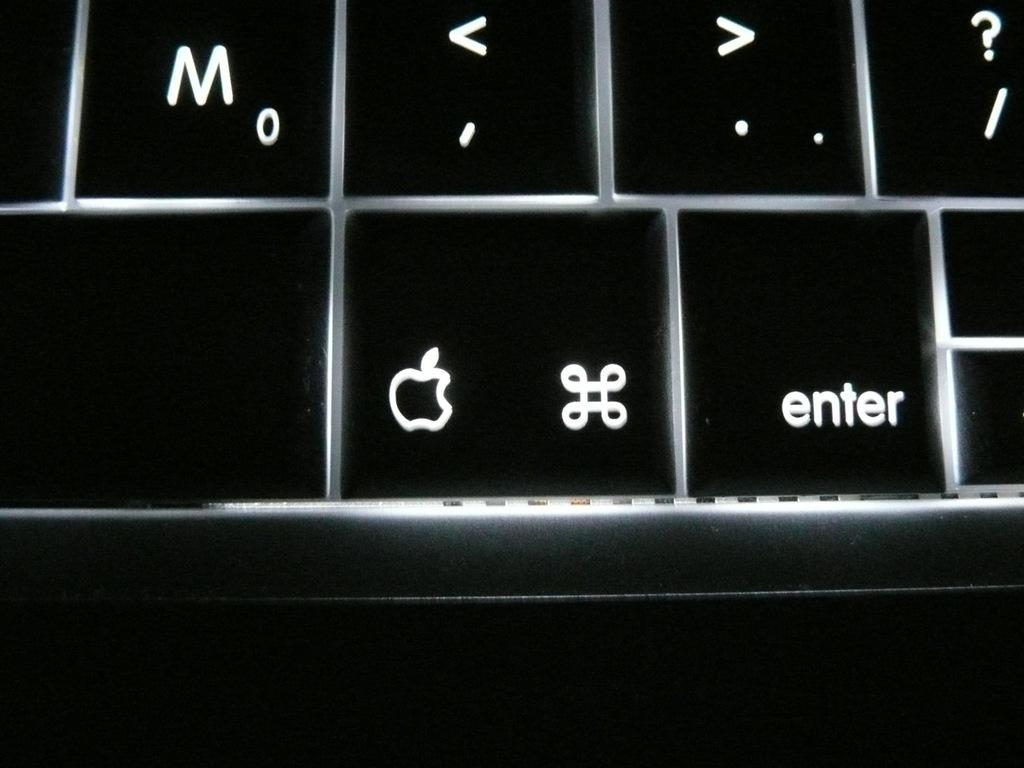<image>
Render a clear and concise summary of the photo. Part of a black keyboard showing the letter M key along with the comma, period, question mark, and an apple key. 